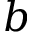Convert formula to latex. <formula><loc_0><loc_0><loc_500><loc_500>b</formula> 